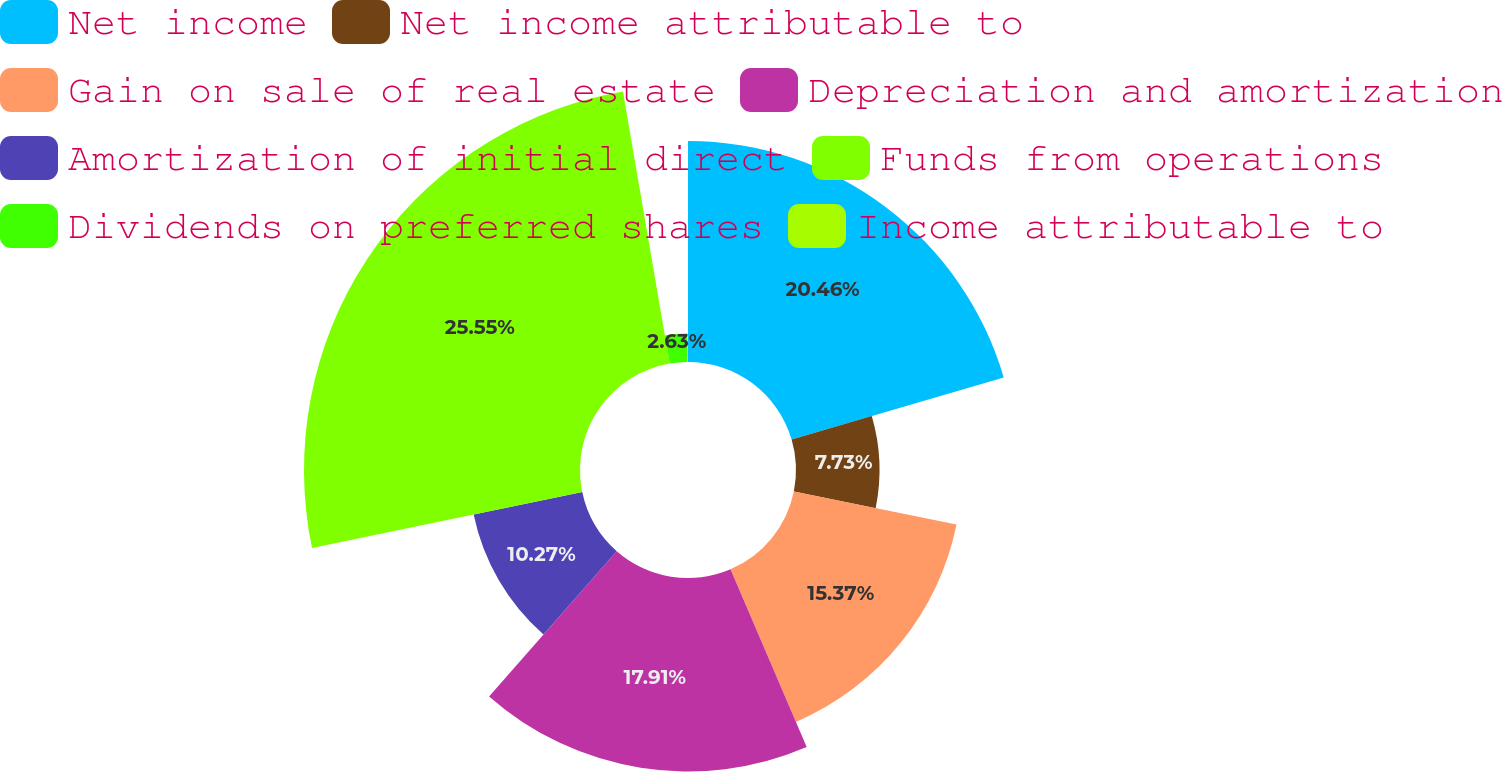Convert chart. <chart><loc_0><loc_0><loc_500><loc_500><pie_chart><fcel>Net income<fcel>Net income attributable to<fcel>Gain on sale of real estate<fcel>Depreciation and amortization<fcel>Amortization of initial direct<fcel>Funds from operations<fcel>Dividends on preferred shares<fcel>Income attributable to<nl><fcel>20.46%<fcel>7.73%<fcel>15.37%<fcel>17.91%<fcel>10.27%<fcel>25.55%<fcel>2.63%<fcel>0.08%<nl></chart> 